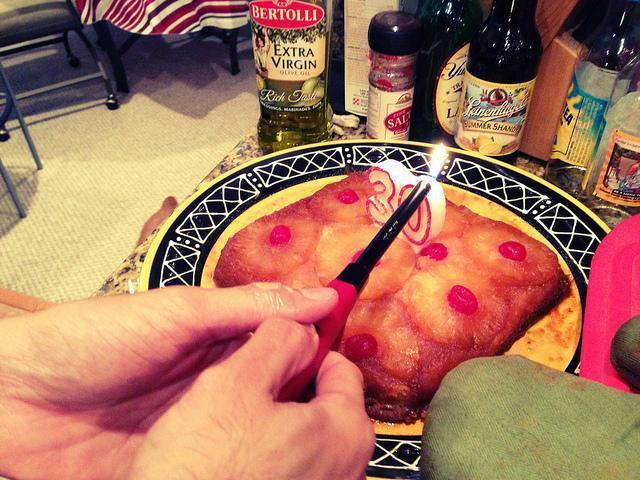How many chairs can you see?
Give a very brief answer. 1. How many dining tables are in the photo?
Give a very brief answer. 2. How many bottles are in the photo?
Give a very brief answer. 7. How many people can you see?
Give a very brief answer. 2. How many giraffes are leaning down to drink?
Give a very brief answer. 0. 